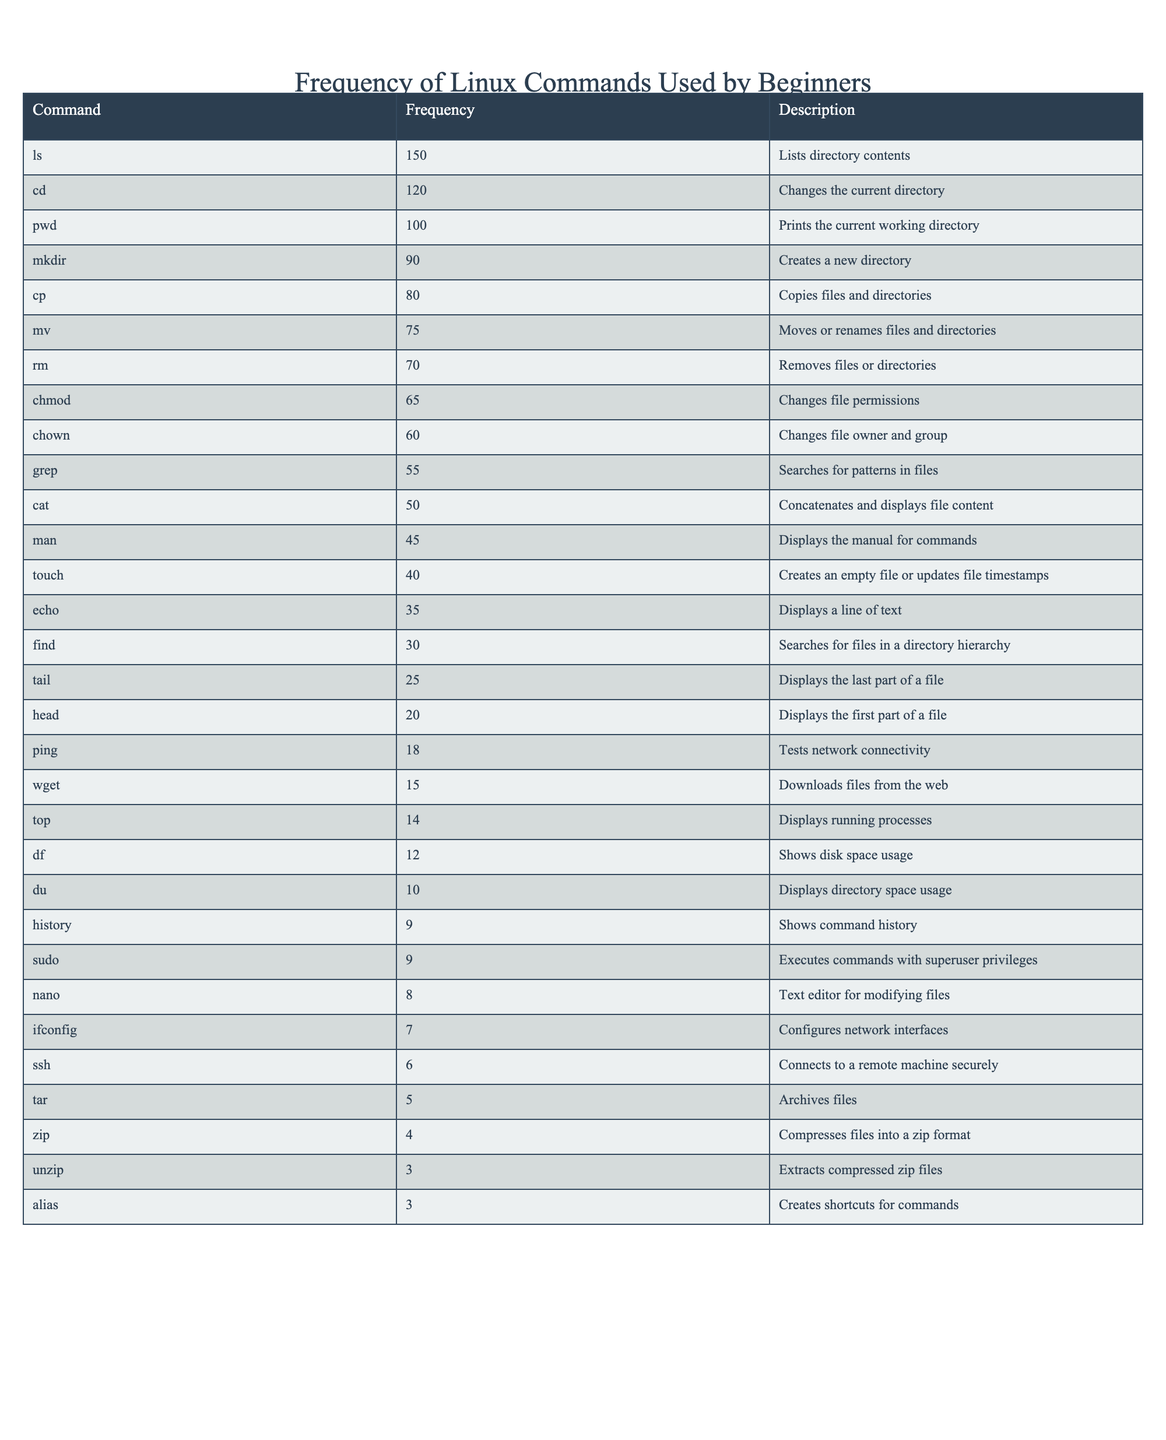What is the most frequently used command by beginners? The table shows that the command 'ls' has the highest frequency of 150, indicating it is the most frequently used command.
Answer: ls How many times was the 'cd' command used compared to 'mv'? The 'cd' command was used 120 times, while the 'mv' command was used 75 times. The difference is 120 - 75 = 45, meaning 'cd' was used 45 times more than 'mv'.
Answer: 45 Is the frequency of the 'wget' command greater than the frequency of the 'ping' command? The 'wget' command has a frequency of 15 and 'ping' has a frequency of 18, so 15 is less than 18, meaning the statement is false.
Answer: No What is the total frequency of the top three commands listed? The top three commands with their respective frequencies are 'ls' (150), 'cd' (120), and 'pwd' (100). Their total is 150 + 120 + 100 = 370.
Answer: 370 Are there more commands used with superuser privileges than network configuration commands? The commands with superuser privileges are 'sudo' (9) and the network-related command is 'ifconfig' (7). Since 9 is greater than 7, the answer is yes.
Answer: Yes What is the average frequency of all the commands listed? To find the average, sum the frequencies: 150 + 120 + 100 + 90 + 80 + 75 + 70 + 65 + 60 + 55 + 50 + 45 + 40 + 35 + 30 + 25 + 20 + 18 + 15 + 14 + 12 + 10 + 9 + 9 + 8 + 7 + 6 + 5 + 4 + 3 + 3 = 1033. There are 30 commands listed so the average frequency is 1033 / 30 ≈ 34.43.
Answer: 34.43 Which command has a frequency closest to the median? First, we need to arrange the command frequencies in order; the median of the sorted list is found at the 15th and 16th positions since there are 30 items. The frequencies at these positions are 30 and 25. The median is (30 + 25) / 2 = 27.5. The command 'find' has a frequency of 30, which is the closest.
Answer: find What is the difference between the frequencies of the 'rm' and 'chmod' commands? The 'rm' command frequency is 70 and the 'chmod' command frequency is 65. The difference is calculated by 70 - 65 = 5.
Answer: 5 Which two commands have the least frequency and how much do they differ? The least used commands are 'unzip' with 3 and 'alias' with 3. The difference between them is 3 - 3 = 0.
Answer: 0 How many commands have a higher frequency than 'cat'? The frequency of 'cat' is 50. Looking at the table, the commands with higher frequencies than 'cat' are 'ls', 'cd', 'pwd', 'mkdir', 'cp', 'mv', 'rm', 'chmod', and 'chown'. There are a total of 9 commands with higher frequencies.
Answer: 9 